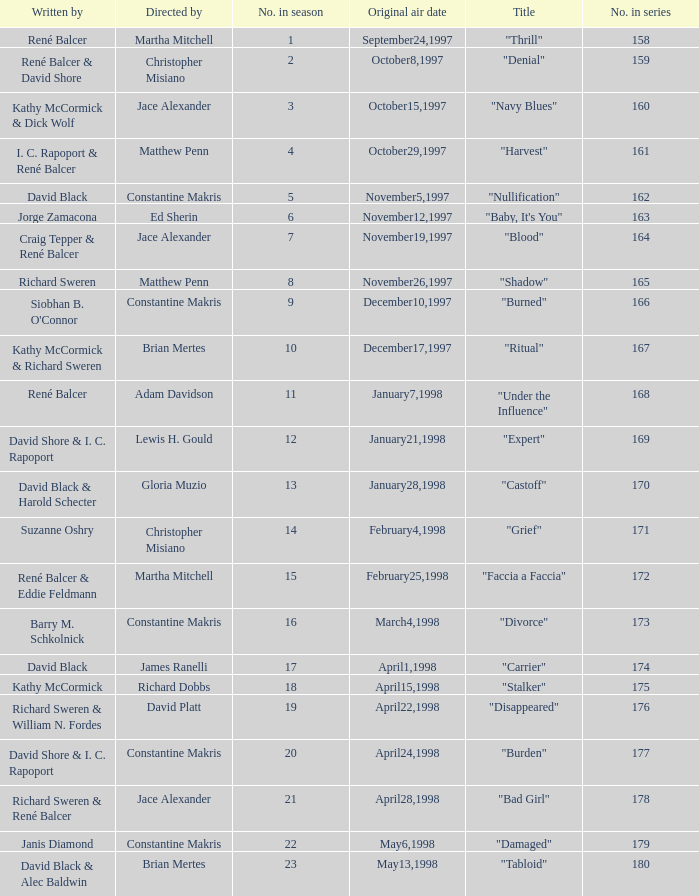The first episode in this season had what number in the series?  158.0. 